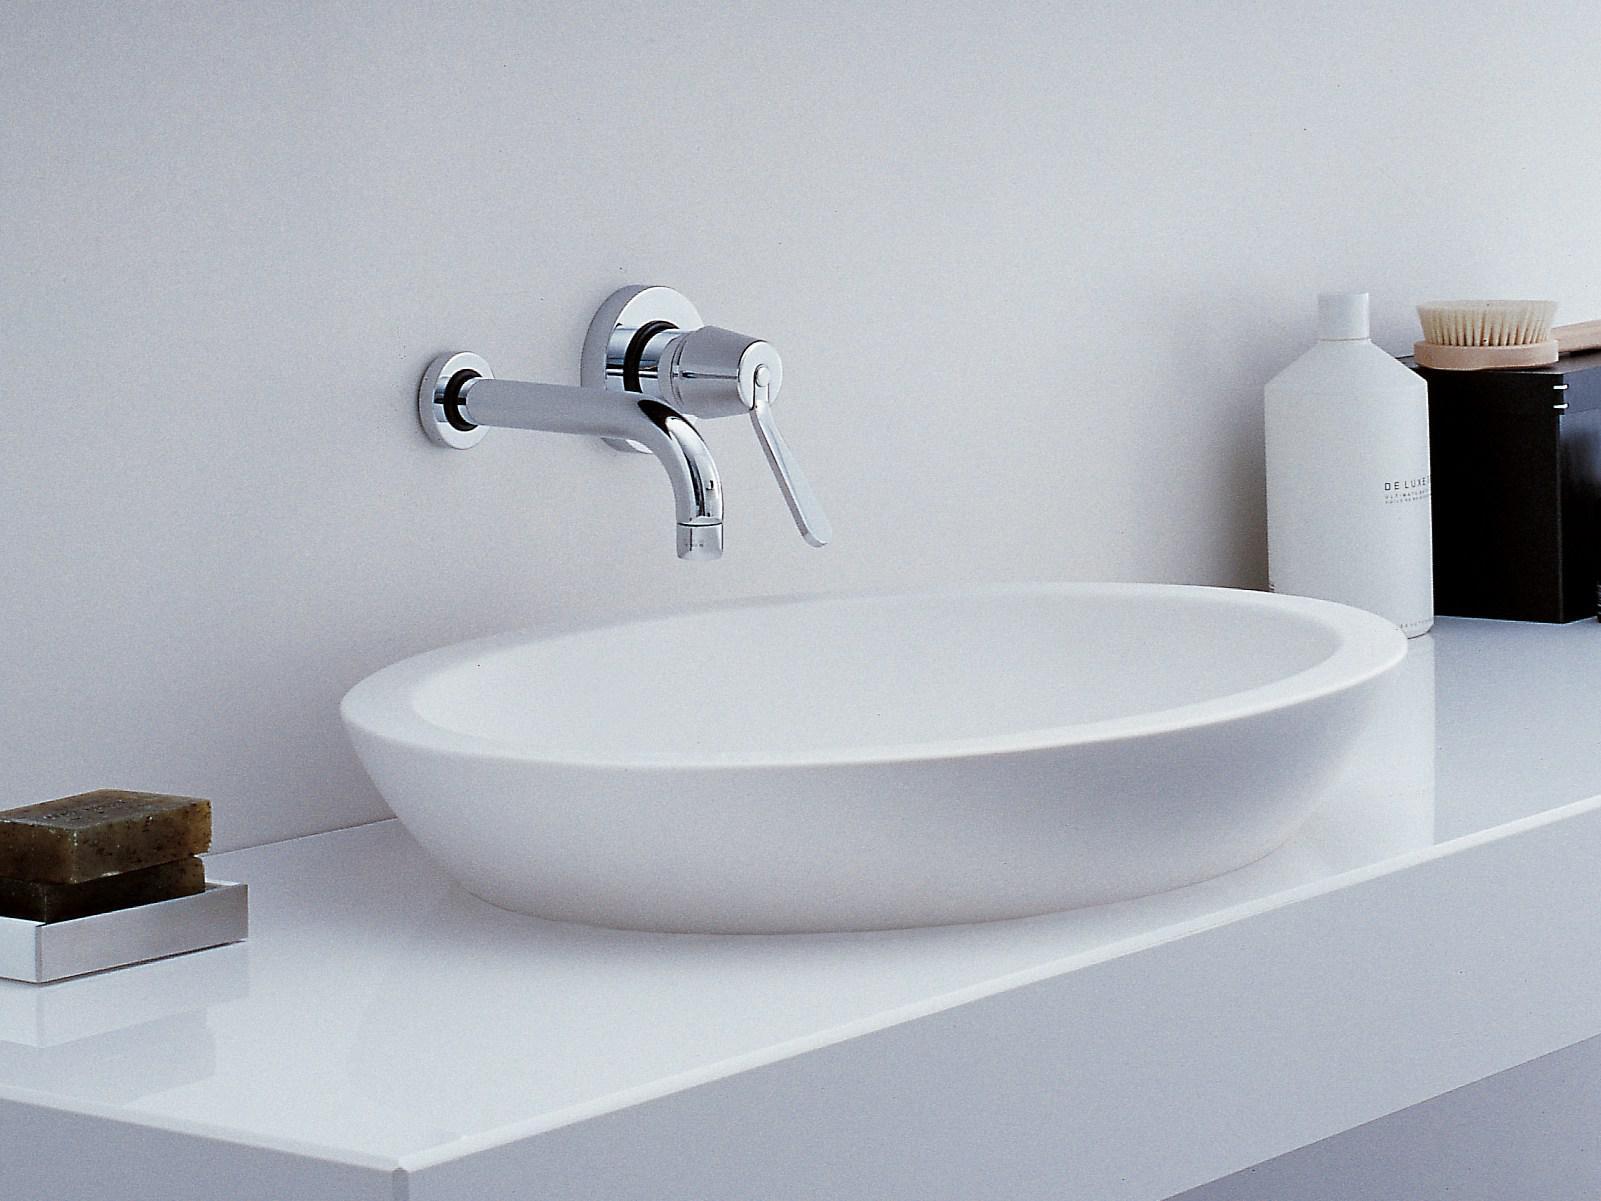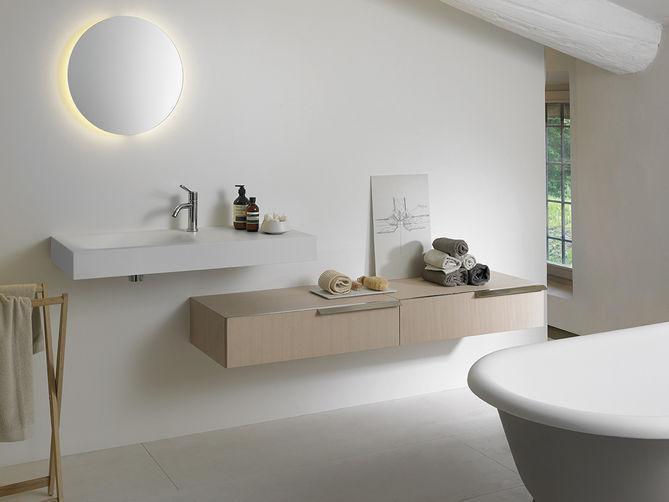The first image is the image on the left, the second image is the image on the right. Evaluate the accuracy of this statement regarding the images: "Every single sink has a basin in the shape of a bowl.". Is it true? Answer yes or no. No. The first image is the image on the left, the second image is the image on the right. Examine the images to the left and right. Is the description "In one image a sink and a bathroom floor are seen." accurate? Answer yes or no. Yes. 